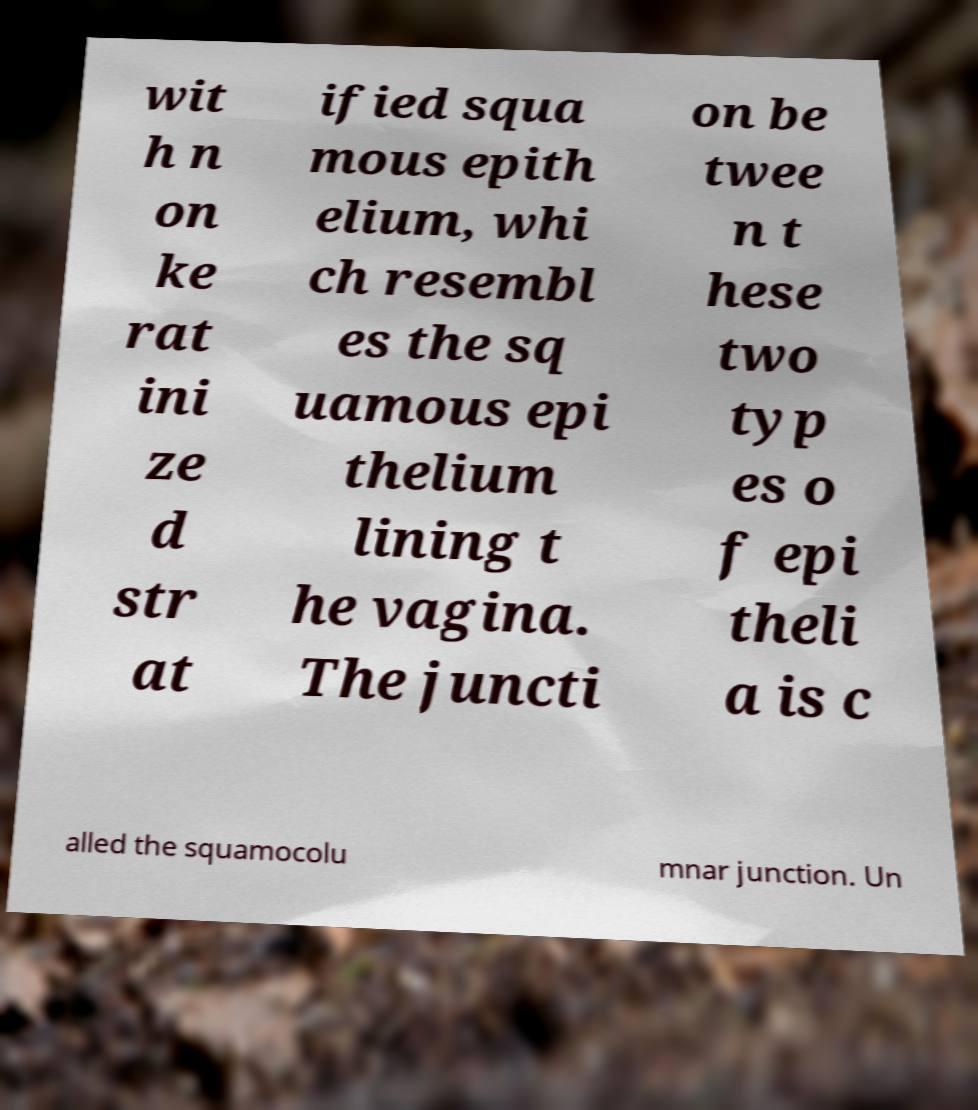Please read and relay the text visible in this image. What does it say? wit h n on ke rat ini ze d str at ified squa mous epith elium, whi ch resembl es the sq uamous epi thelium lining t he vagina. The juncti on be twee n t hese two typ es o f epi theli a is c alled the squamocolu mnar junction. Un 